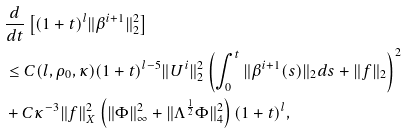<formula> <loc_0><loc_0><loc_500><loc_500>& \frac { d } { d t } \left [ ( 1 + t ) ^ { l } \| \beta ^ { i + 1 } \| _ { 2 } ^ { 2 } \right ] \\ & \leq C ( l , \rho _ { 0 } , \kappa ) ( 1 + t ) ^ { l - 5 } \| U ^ { i } \| _ { 2 } ^ { 2 } \left ( \int _ { 0 } ^ { t } \| \beta ^ { i + 1 } ( s ) \| _ { 2 } d s + \| f \| _ { 2 } \right ) ^ { 2 } \\ & + C \kappa ^ { - 3 } \| f \| _ { X } ^ { 2 } \left ( \| \Phi \| _ { \infty } ^ { 2 } + \| \Lambda ^ { \frac { 1 } { 2 } } \Phi \| _ { 4 } ^ { 2 } \right ) ( 1 + t ) ^ { l } ,</formula> 